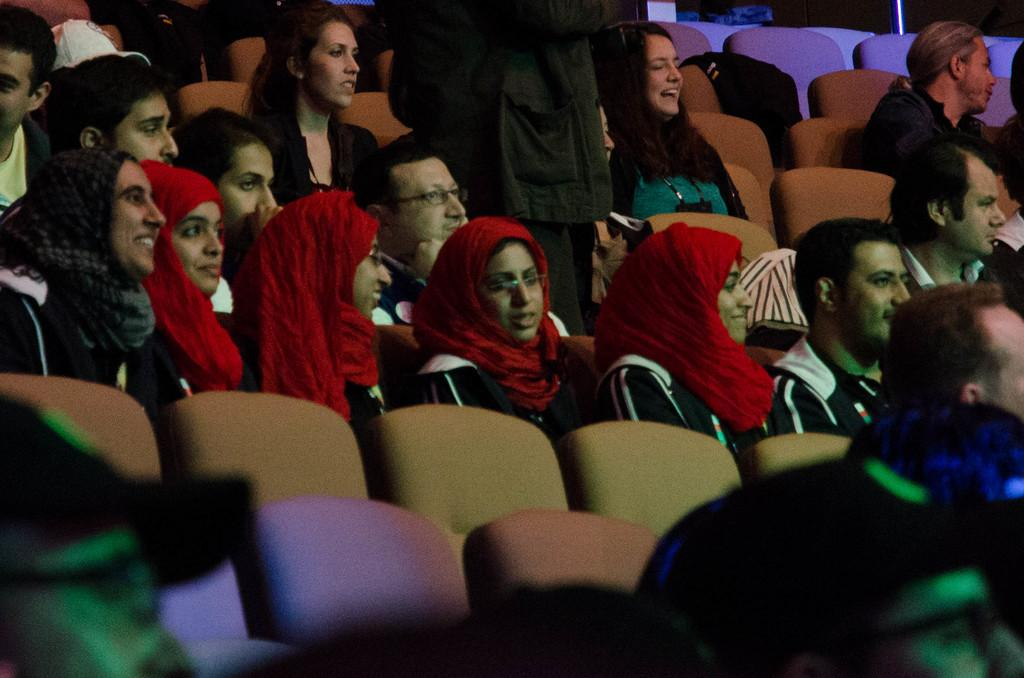What are the people in the image doing? The persons in the image are sitting on chairs. Are there any chairs that are not occupied in the image? Yes, there are empty chairs in the image. What is the position of the person who is not sitting in the image? There is a person standing in the image. What type of destruction can be seen on the bed in the image? There is no bed present in the image, so it is not possible to determine if there is any destruction. 